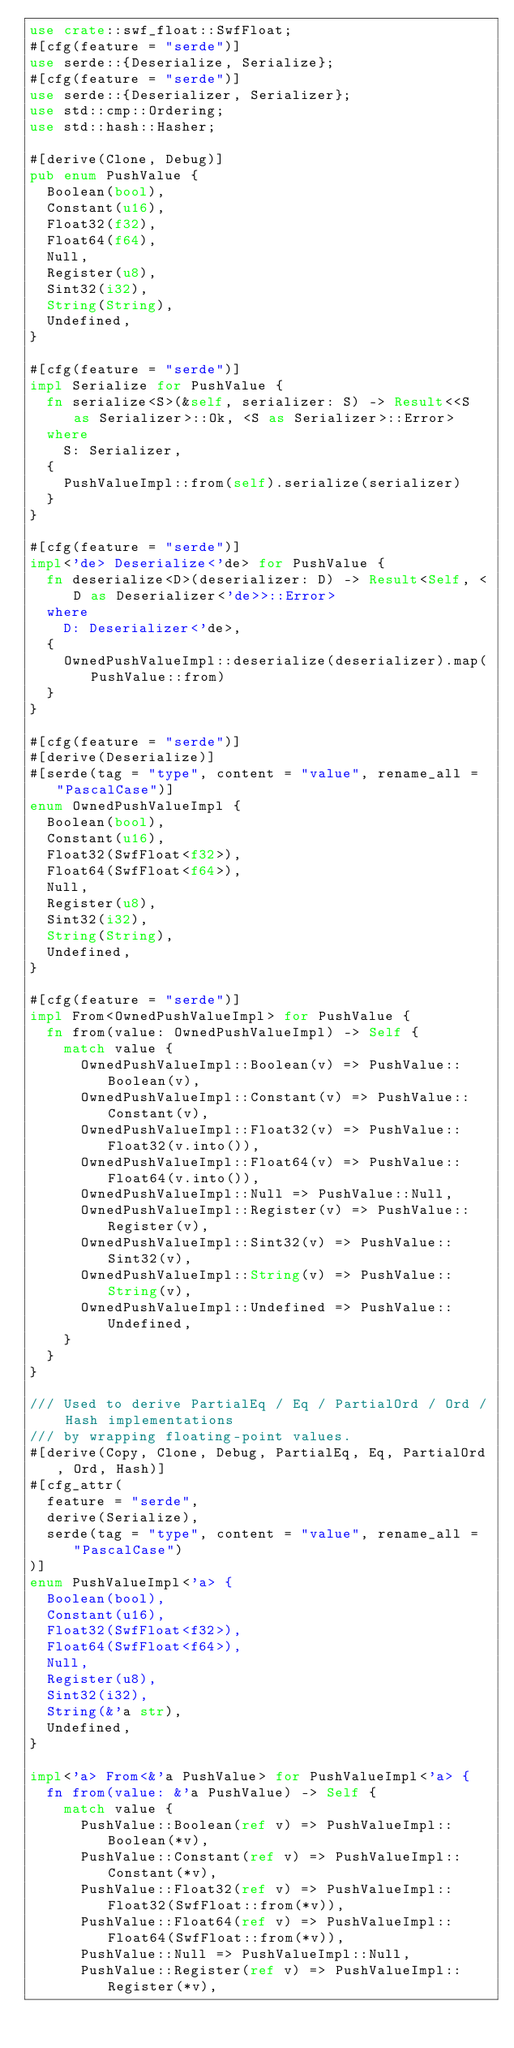<code> <loc_0><loc_0><loc_500><loc_500><_Rust_>use crate::swf_float::SwfFloat;
#[cfg(feature = "serde")]
use serde::{Deserialize, Serialize};
#[cfg(feature = "serde")]
use serde::{Deserializer, Serializer};
use std::cmp::Ordering;
use std::hash::Hasher;

#[derive(Clone, Debug)]
pub enum PushValue {
  Boolean(bool),
  Constant(u16),
  Float32(f32),
  Float64(f64),
  Null,
  Register(u8),
  Sint32(i32),
  String(String),
  Undefined,
}

#[cfg(feature = "serde")]
impl Serialize for PushValue {
  fn serialize<S>(&self, serializer: S) -> Result<<S as Serializer>::Ok, <S as Serializer>::Error>
  where
    S: Serializer,
  {
    PushValueImpl::from(self).serialize(serializer)
  }
}

#[cfg(feature = "serde")]
impl<'de> Deserialize<'de> for PushValue {
  fn deserialize<D>(deserializer: D) -> Result<Self, <D as Deserializer<'de>>::Error>
  where
    D: Deserializer<'de>,
  {
    OwnedPushValueImpl::deserialize(deserializer).map(PushValue::from)
  }
}

#[cfg(feature = "serde")]
#[derive(Deserialize)]
#[serde(tag = "type", content = "value", rename_all = "PascalCase")]
enum OwnedPushValueImpl {
  Boolean(bool),
  Constant(u16),
  Float32(SwfFloat<f32>),
  Float64(SwfFloat<f64>),
  Null,
  Register(u8),
  Sint32(i32),
  String(String),
  Undefined,
}

#[cfg(feature = "serde")]
impl From<OwnedPushValueImpl> for PushValue {
  fn from(value: OwnedPushValueImpl) -> Self {
    match value {
      OwnedPushValueImpl::Boolean(v) => PushValue::Boolean(v),
      OwnedPushValueImpl::Constant(v) => PushValue::Constant(v),
      OwnedPushValueImpl::Float32(v) => PushValue::Float32(v.into()),
      OwnedPushValueImpl::Float64(v) => PushValue::Float64(v.into()),
      OwnedPushValueImpl::Null => PushValue::Null,
      OwnedPushValueImpl::Register(v) => PushValue::Register(v),
      OwnedPushValueImpl::Sint32(v) => PushValue::Sint32(v),
      OwnedPushValueImpl::String(v) => PushValue::String(v),
      OwnedPushValueImpl::Undefined => PushValue::Undefined,
    }
  }
}

/// Used to derive PartialEq / Eq / PartialOrd / Ord / Hash implementations
/// by wrapping floating-point values.
#[derive(Copy, Clone, Debug, PartialEq, Eq, PartialOrd, Ord, Hash)]
#[cfg_attr(
  feature = "serde",
  derive(Serialize),
  serde(tag = "type", content = "value", rename_all = "PascalCase")
)]
enum PushValueImpl<'a> {
  Boolean(bool),
  Constant(u16),
  Float32(SwfFloat<f32>),
  Float64(SwfFloat<f64>),
  Null,
  Register(u8),
  Sint32(i32),
  String(&'a str),
  Undefined,
}

impl<'a> From<&'a PushValue> for PushValueImpl<'a> {
  fn from(value: &'a PushValue) -> Self {
    match value {
      PushValue::Boolean(ref v) => PushValueImpl::Boolean(*v),
      PushValue::Constant(ref v) => PushValueImpl::Constant(*v),
      PushValue::Float32(ref v) => PushValueImpl::Float32(SwfFloat::from(*v)),
      PushValue::Float64(ref v) => PushValueImpl::Float64(SwfFloat::from(*v)),
      PushValue::Null => PushValueImpl::Null,
      PushValue::Register(ref v) => PushValueImpl::Register(*v),</code> 